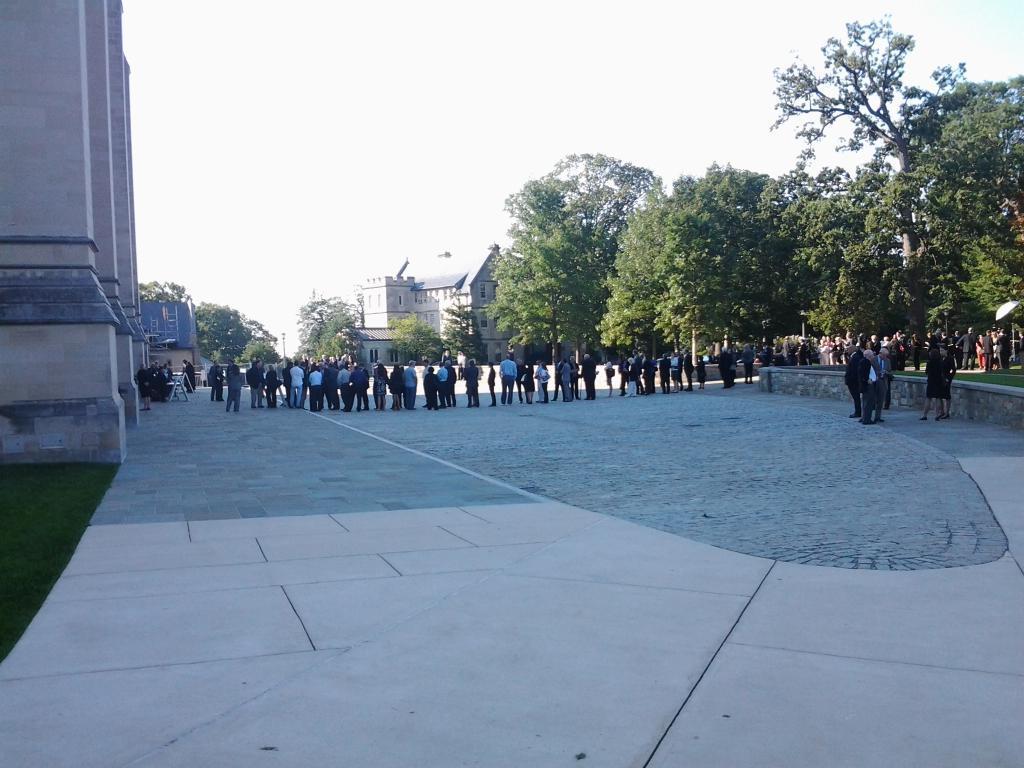Can you describe this image briefly? At the bottom of the image there is a floor with many people are standing. In the top left corner of the image there are pillars. In the background there are many trees and also there are buildings. At the top of the image there is sky. 